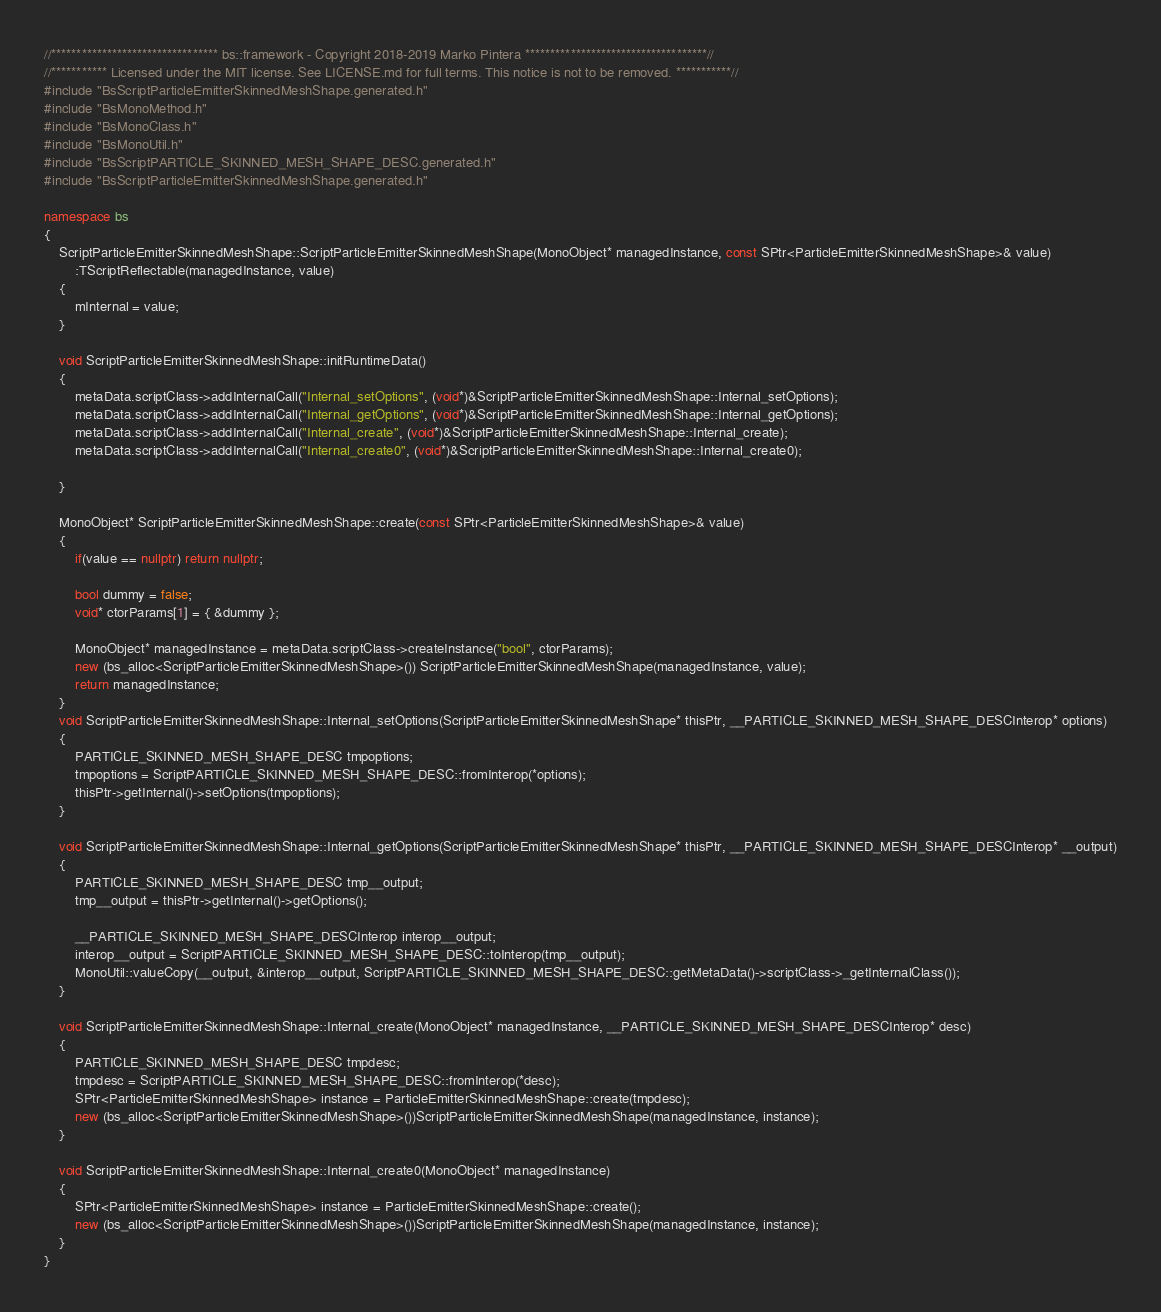Convert code to text. <code><loc_0><loc_0><loc_500><loc_500><_C++_>//********************************* bs::framework - Copyright 2018-2019 Marko Pintera ************************************//
//*********** Licensed under the MIT license. See LICENSE.md for full terms. This notice is not to be removed. ***********//
#include "BsScriptParticleEmitterSkinnedMeshShape.generated.h"
#include "BsMonoMethod.h"
#include "BsMonoClass.h"
#include "BsMonoUtil.h"
#include "BsScriptPARTICLE_SKINNED_MESH_SHAPE_DESC.generated.h"
#include "BsScriptParticleEmitterSkinnedMeshShape.generated.h"

namespace bs
{
	ScriptParticleEmitterSkinnedMeshShape::ScriptParticleEmitterSkinnedMeshShape(MonoObject* managedInstance, const SPtr<ParticleEmitterSkinnedMeshShape>& value)
		:TScriptReflectable(managedInstance, value)
	{
		mInternal = value;
	}

	void ScriptParticleEmitterSkinnedMeshShape::initRuntimeData()
	{
		metaData.scriptClass->addInternalCall("Internal_setOptions", (void*)&ScriptParticleEmitterSkinnedMeshShape::Internal_setOptions);
		metaData.scriptClass->addInternalCall("Internal_getOptions", (void*)&ScriptParticleEmitterSkinnedMeshShape::Internal_getOptions);
		metaData.scriptClass->addInternalCall("Internal_create", (void*)&ScriptParticleEmitterSkinnedMeshShape::Internal_create);
		metaData.scriptClass->addInternalCall("Internal_create0", (void*)&ScriptParticleEmitterSkinnedMeshShape::Internal_create0);

	}

	MonoObject* ScriptParticleEmitterSkinnedMeshShape::create(const SPtr<ParticleEmitterSkinnedMeshShape>& value)
	{
		if(value == nullptr) return nullptr; 

		bool dummy = false;
		void* ctorParams[1] = { &dummy };

		MonoObject* managedInstance = metaData.scriptClass->createInstance("bool", ctorParams);
		new (bs_alloc<ScriptParticleEmitterSkinnedMeshShape>()) ScriptParticleEmitterSkinnedMeshShape(managedInstance, value);
		return managedInstance;
	}
	void ScriptParticleEmitterSkinnedMeshShape::Internal_setOptions(ScriptParticleEmitterSkinnedMeshShape* thisPtr, __PARTICLE_SKINNED_MESH_SHAPE_DESCInterop* options)
	{
		PARTICLE_SKINNED_MESH_SHAPE_DESC tmpoptions;
		tmpoptions = ScriptPARTICLE_SKINNED_MESH_SHAPE_DESC::fromInterop(*options);
		thisPtr->getInternal()->setOptions(tmpoptions);
	}

	void ScriptParticleEmitterSkinnedMeshShape::Internal_getOptions(ScriptParticleEmitterSkinnedMeshShape* thisPtr, __PARTICLE_SKINNED_MESH_SHAPE_DESCInterop* __output)
	{
		PARTICLE_SKINNED_MESH_SHAPE_DESC tmp__output;
		tmp__output = thisPtr->getInternal()->getOptions();

		__PARTICLE_SKINNED_MESH_SHAPE_DESCInterop interop__output;
		interop__output = ScriptPARTICLE_SKINNED_MESH_SHAPE_DESC::toInterop(tmp__output);
		MonoUtil::valueCopy(__output, &interop__output, ScriptPARTICLE_SKINNED_MESH_SHAPE_DESC::getMetaData()->scriptClass->_getInternalClass());
	}

	void ScriptParticleEmitterSkinnedMeshShape::Internal_create(MonoObject* managedInstance, __PARTICLE_SKINNED_MESH_SHAPE_DESCInterop* desc)
	{
		PARTICLE_SKINNED_MESH_SHAPE_DESC tmpdesc;
		tmpdesc = ScriptPARTICLE_SKINNED_MESH_SHAPE_DESC::fromInterop(*desc);
		SPtr<ParticleEmitterSkinnedMeshShape> instance = ParticleEmitterSkinnedMeshShape::create(tmpdesc);
		new (bs_alloc<ScriptParticleEmitterSkinnedMeshShape>())ScriptParticleEmitterSkinnedMeshShape(managedInstance, instance);
	}

	void ScriptParticleEmitterSkinnedMeshShape::Internal_create0(MonoObject* managedInstance)
	{
		SPtr<ParticleEmitterSkinnedMeshShape> instance = ParticleEmitterSkinnedMeshShape::create();
		new (bs_alloc<ScriptParticleEmitterSkinnedMeshShape>())ScriptParticleEmitterSkinnedMeshShape(managedInstance, instance);
	}
}
</code> 